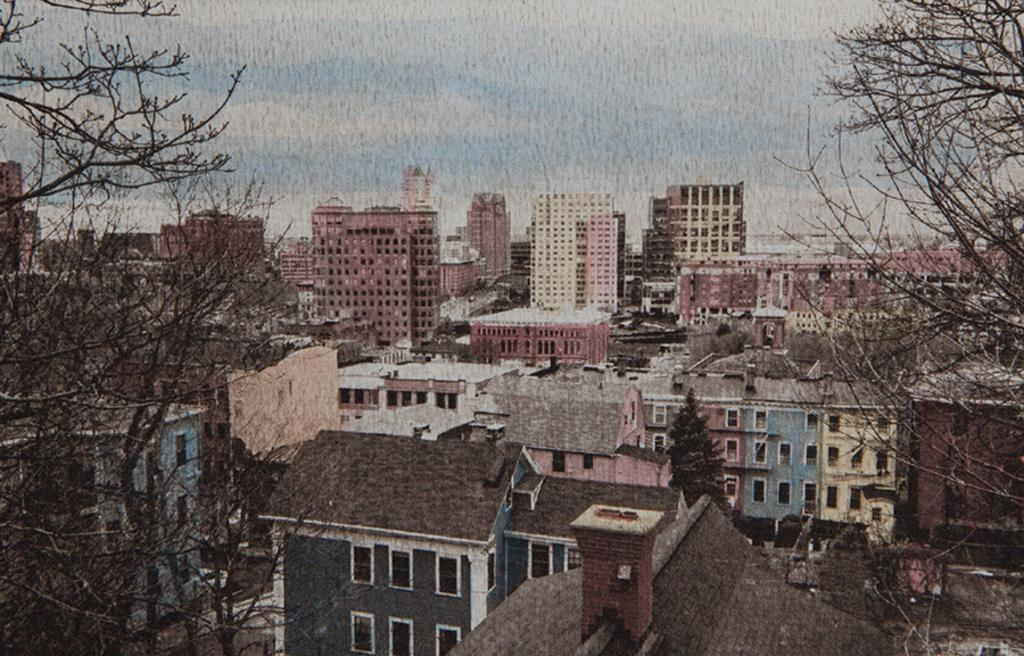What type of structures can be seen in the image? There are buildings in the image. What other natural elements are present in the image? There are trees in the image. What part of the natural environment is visible in the image? The sky is visible in the image. What type of crow can be seen flying in the image? There is no crow present in the image; it only features buildings, trees, and the sky. 